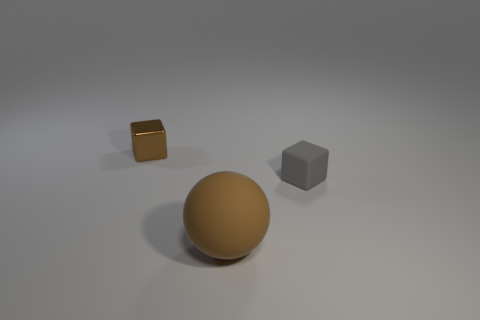Add 2 big brown rubber objects. How many objects exist? 5 Add 3 brown rubber objects. How many brown rubber objects exist? 4 Subtract 0 green cylinders. How many objects are left? 3 Subtract all cubes. How many objects are left? 1 Subtract all large purple spheres. Subtract all tiny rubber things. How many objects are left? 2 Add 2 tiny gray cubes. How many tiny gray cubes are left? 3 